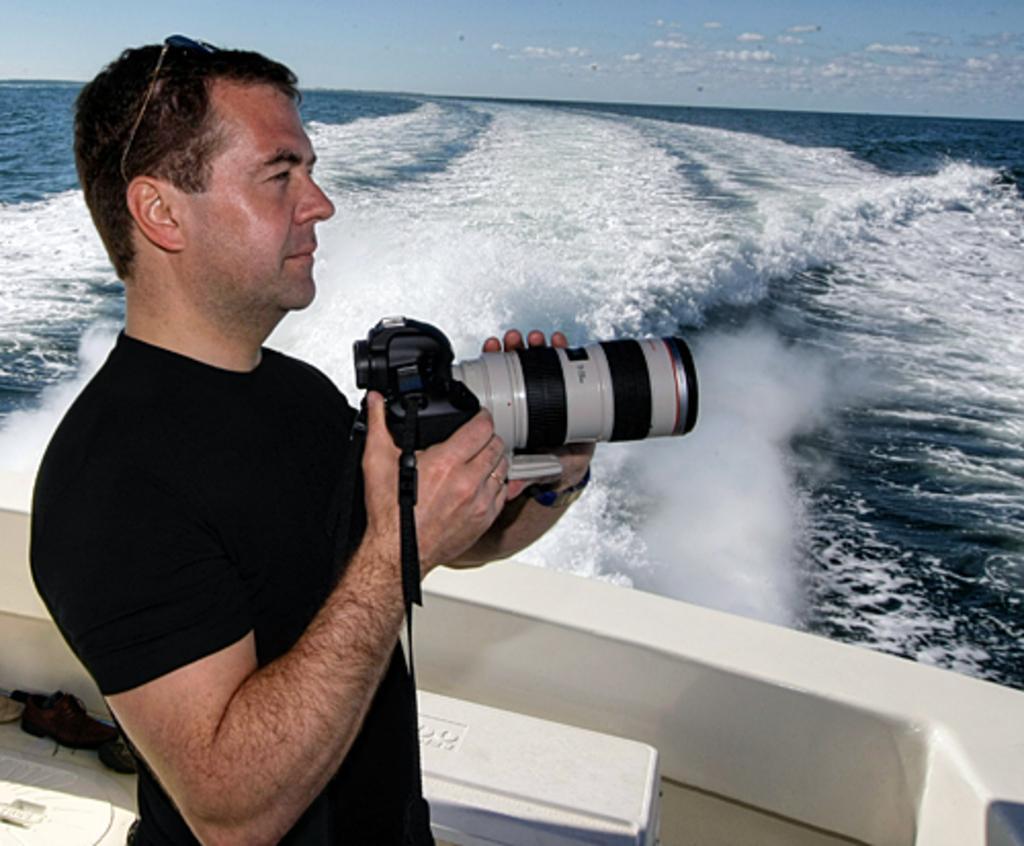Could you give a brief overview of what you see in this image? In this image a man holding a camera in his hands and we can see water. 